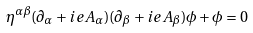Convert formula to latex. <formula><loc_0><loc_0><loc_500><loc_500>\eta ^ { \alpha \beta } ( \partial _ { \alpha } + i e A _ { \alpha } ) ( \partial _ { \beta } + i e A _ { \beta } ) \phi + \phi = 0</formula> 